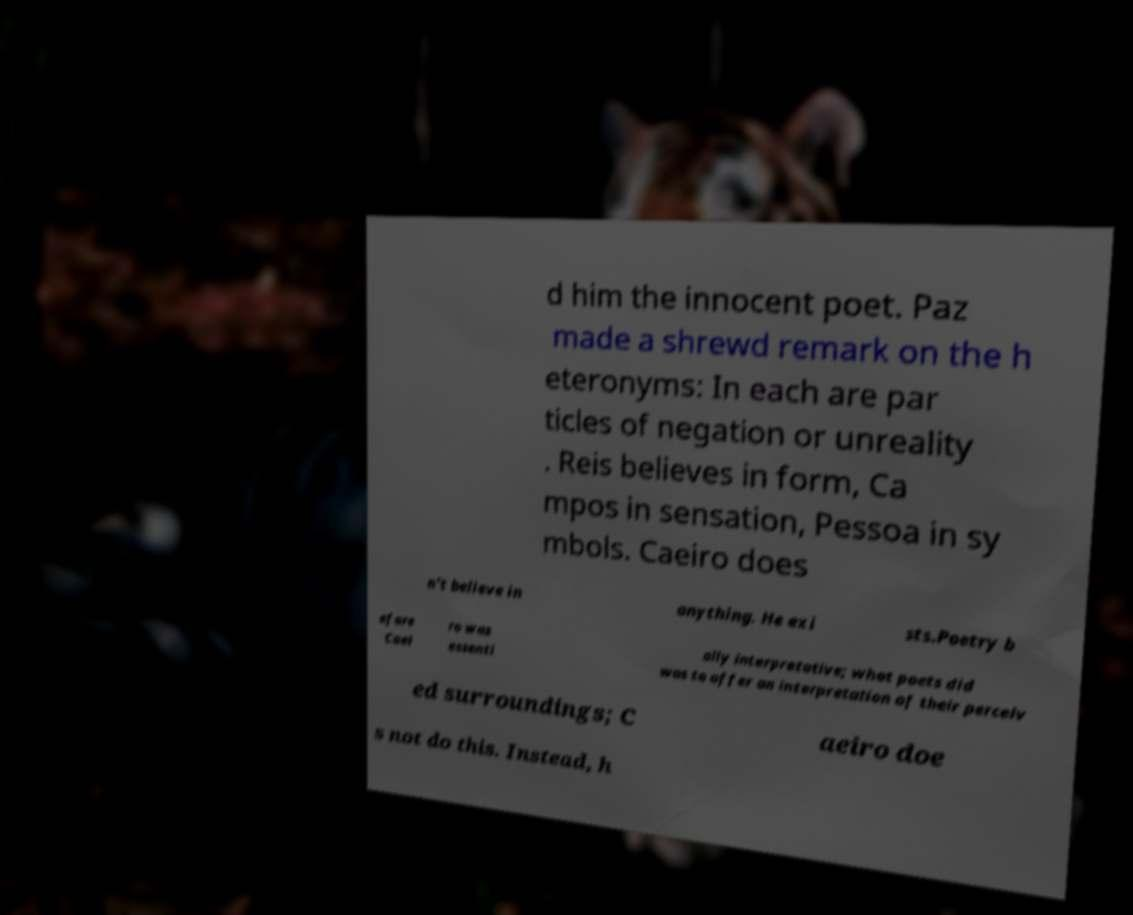There's text embedded in this image that I need extracted. Can you transcribe it verbatim? d him the innocent poet. Paz made a shrewd remark on the h eteronyms: In each are par ticles of negation or unreality . Reis believes in form, Ca mpos in sensation, Pessoa in sy mbols. Caeiro does n't believe in anything. He exi sts.Poetry b efore Caei ro was essenti ally interpretative; what poets did was to offer an interpretation of their perceiv ed surroundings; C aeiro doe s not do this. Instead, h 